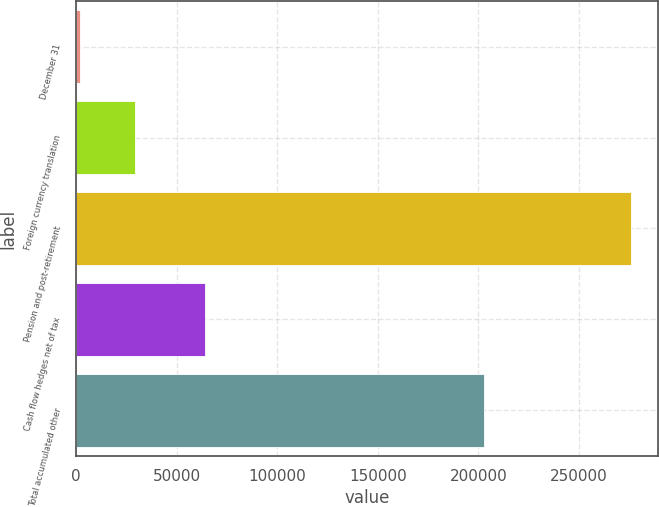Convert chart to OTSL. <chart><loc_0><loc_0><loc_500><loc_500><bar_chart><fcel>December 31<fcel>Foreign currency translation<fcel>Pension and post-retirement<fcel>Cash flow hedges net of tax<fcel>Total accumulated other<nl><fcel>2009<fcel>29379.1<fcel>275710<fcel>64317<fcel>202844<nl></chart> 